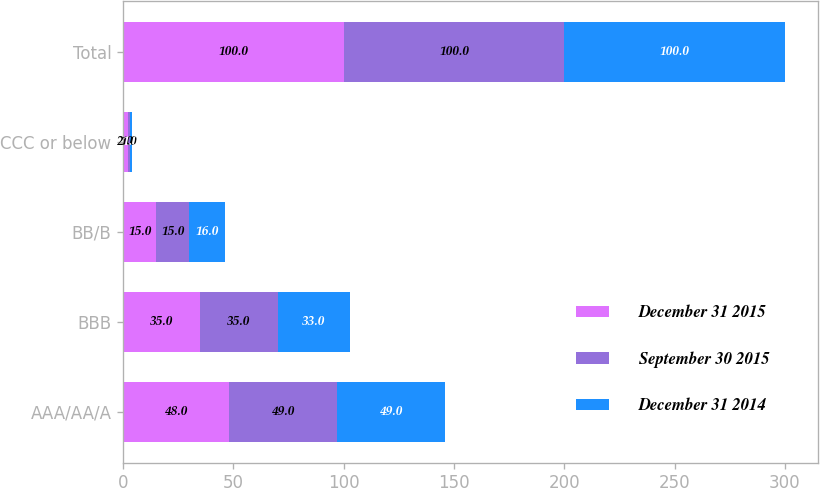Convert chart. <chart><loc_0><loc_0><loc_500><loc_500><stacked_bar_chart><ecel><fcel>AAA/AA/A<fcel>BBB<fcel>BB/B<fcel>CCC or below<fcel>Total<nl><fcel>December 31 2015<fcel>48<fcel>35<fcel>15<fcel>2<fcel>100<nl><fcel>September 30 2015<fcel>49<fcel>35<fcel>15<fcel>1<fcel>100<nl><fcel>December 31 2014<fcel>49<fcel>33<fcel>16<fcel>1<fcel>100<nl></chart> 